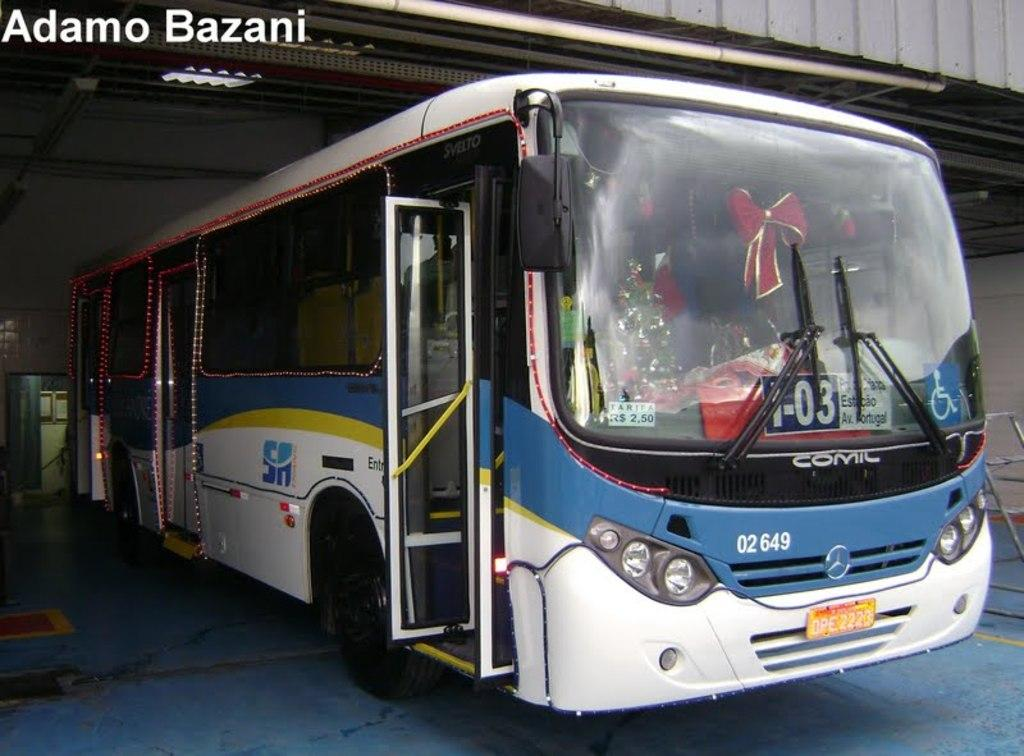What is the main subject of the image? The main subject of the image is a bus. Where is the bus located in the image? The bus is under a roof in the image. What other object can be seen on the floor in the image? There is a ladder on the floor in the image. How many flowers are on the bus in the image? There are no flowers present on the bus in the image. Can you tell me how many friends are sitting inside the bus? The image does not show the inside of the bus, so it is not possible to determine how many friends are sitting inside. 